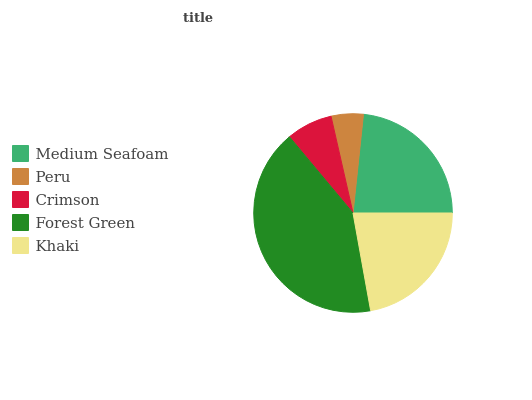Is Peru the minimum?
Answer yes or no. Yes. Is Forest Green the maximum?
Answer yes or no. Yes. Is Crimson the minimum?
Answer yes or no. No. Is Crimson the maximum?
Answer yes or no. No. Is Crimson greater than Peru?
Answer yes or no. Yes. Is Peru less than Crimson?
Answer yes or no. Yes. Is Peru greater than Crimson?
Answer yes or no. No. Is Crimson less than Peru?
Answer yes or no. No. Is Khaki the high median?
Answer yes or no. Yes. Is Khaki the low median?
Answer yes or no. Yes. Is Peru the high median?
Answer yes or no. No. Is Medium Seafoam the low median?
Answer yes or no. No. 